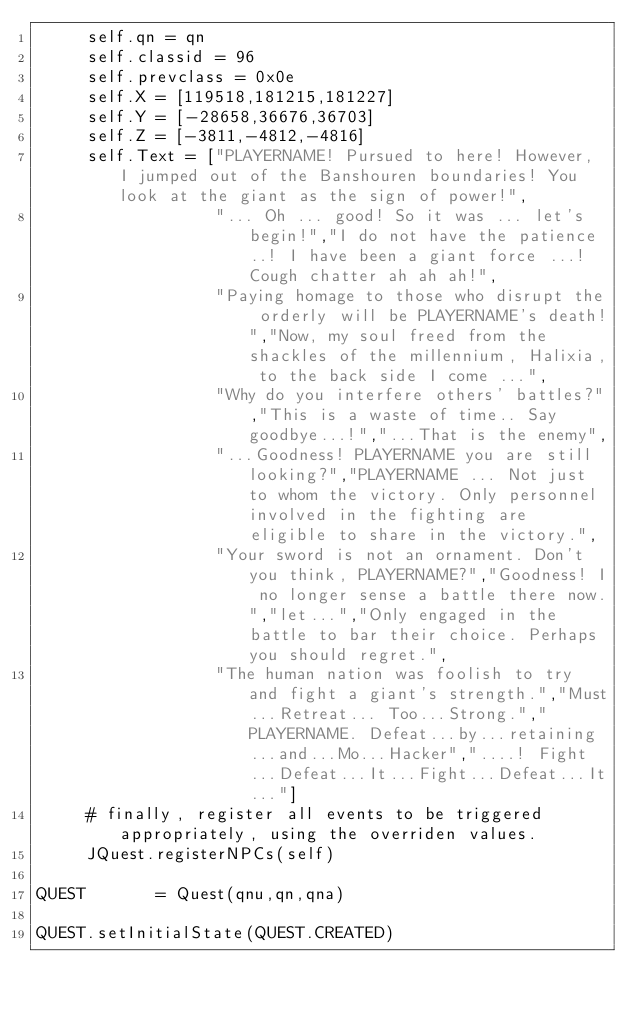Convert code to text. <code><loc_0><loc_0><loc_500><loc_500><_Python_>     self.qn = qn
     self.classid = 96
     self.prevclass = 0x0e
     self.X = [119518,181215,181227]
     self.Y = [-28658,36676,36703]
     self.Z = [-3811,-4812,-4816]
     self.Text = ["PLAYERNAME! Pursued to here! However, I jumped out of the Banshouren boundaries! You look at the giant as the sign of power!",
                  "... Oh ... good! So it was ... let's begin!","I do not have the patience ..! I have been a giant force ...! Cough chatter ah ah ah!",
                  "Paying homage to those who disrupt the orderly will be PLAYERNAME's death!","Now, my soul freed from the shackles of the millennium, Halixia, to the back side I come ...",
                  "Why do you interfere others' battles?","This is a waste of time.. Say goodbye...!","...That is the enemy",
                  "...Goodness! PLAYERNAME you are still looking?","PLAYERNAME ... Not just to whom the victory. Only personnel involved in the fighting are eligible to share in the victory.",
                  "Your sword is not an ornament. Don't you think, PLAYERNAME?","Goodness! I no longer sense a battle there now.","let...","Only engaged in the battle to bar their choice. Perhaps you should regret.",
                  "The human nation was foolish to try and fight a giant's strength.","Must...Retreat... Too...Strong.","PLAYERNAME. Defeat...by...retaining...and...Mo...Hacker","....! Fight...Defeat...It...Fight...Defeat...It..."]
     # finally, register all events to be triggered appropriately, using the overriden values.
     JQuest.registerNPCs(self)

QUEST       = Quest(qnu,qn,qna)

QUEST.setInitialState(QUEST.CREATED)</code> 